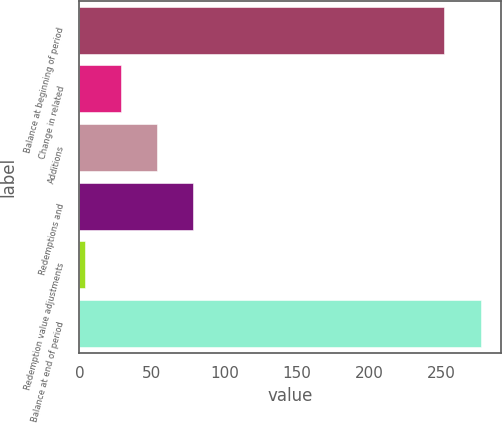Convert chart to OTSL. <chart><loc_0><loc_0><loc_500><loc_500><bar_chart><fcel>Balance at beginning of period<fcel>Change in related<fcel>Additions<fcel>Redemptions and<fcel>Redemption value adjustments<fcel>Balance at end of period<nl><fcel>251.9<fcel>28.88<fcel>53.76<fcel>78.64<fcel>4<fcel>276.78<nl></chart> 